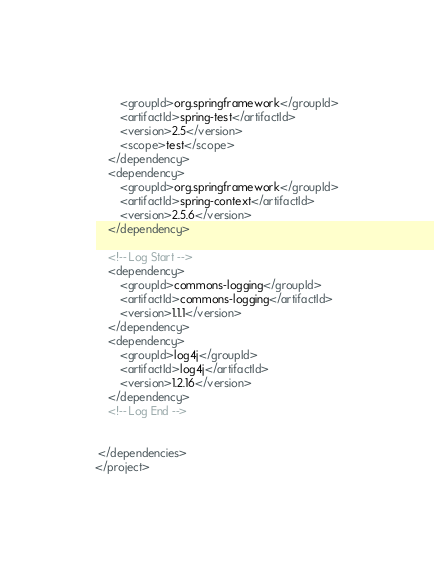<code> <loc_0><loc_0><loc_500><loc_500><_XML_>    	<groupId>org.springframework</groupId>
    	<artifactId>spring-test</artifactId>
    	<version>2.5</version>
    	<scope>test</scope>
	</dependency>
	<dependency>
		<groupId>org.springframework</groupId>
		<artifactId>spring-context</artifactId>
		<version>2.5.6</version>
	</dependency>
    
    <!-- Log Start -->
    <dependency>
		<groupId>commons-logging</groupId>
		<artifactId>commons-logging</artifactId>
		<version>1.1.1</version>
	</dependency>
	<dependency>
		<groupId>log4j</groupId>
		<artifactId>log4j</artifactId>
		<version>1.2.16</version>
	</dependency>
	<!-- Log End -->


 </dependencies>
</project>
</code> 